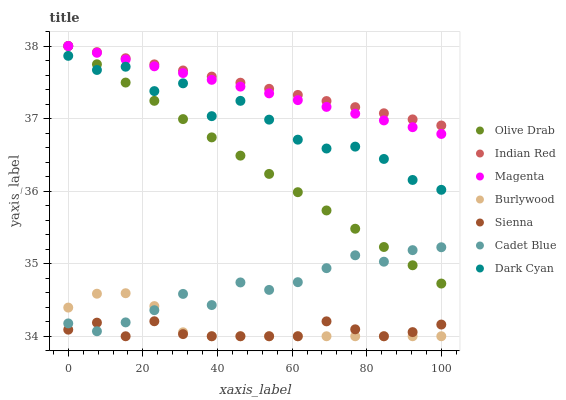Does Sienna have the minimum area under the curve?
Answer yes or no. Yes. Does Indian Red have the maximum area under the curve?
Answer yes or no. Yes. Does Burlywood have the minimum area under the curve?
Answer yes or no. No. Does Burlywood have the maximum area under the curve?
Answer yes or no. No. Is Indian Red the smoothest?
Answer yes or no. Yes. Is Dark Cyan the roughest?
Answer yes or no. Yes. Is Burlywood the smoothest?
Answer yes or no. No. Is Burlywood the roughest?
Answer yes or no. No. Does Burlywood have the lowest value?
Answer yes or no. Yes. Does Indian Red have the lowest value?
Answer yes or no. No. Does Olive Drab have the highest value?
Answer yes or no. Yes. Does Burlywood have the highest value?
Answer yes or no. No. Is Dark Cyan less than Magenta?
Answer yes or no. Yes. Is Olive Drab greater than Burlywood?
Answer yes or no. Yes. Does Burlywood intersect Cadet Blue?
Answer yes or no. Yes. Is Burlywood less than Cadet Blue?
Answer yes or no. No. Is Burlywood greater than Cadet Blue?
Answer yes or no. No. Does Dark Cyan intersect Magenta?
Answer yes or no. No. 